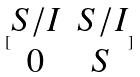<formula> <loc_0><loc_0><loc_500><loc_500>[ \begin{matrix} S / I & S / I \\ 0 & S \end{matrix} ]</formula> 